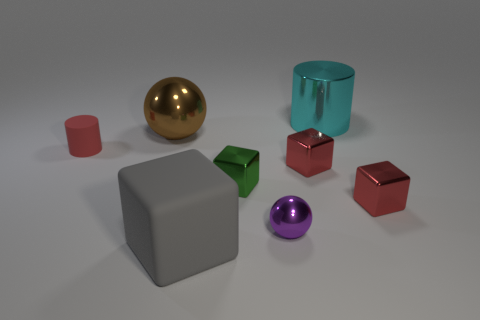Does the red thing on the left side of the big brown metal sphere have the same shape as the shiny object behind the large brown metal ball?
Your response must be concise. Yes. How many purple things are to the left of the metallic cylinder?
Give a very brief answer. 1. Is the big cube that is in front of the cyan cylinder made of the same material as the small red cylinder?
Provide a succinct answer. Yes. What is the color of the shiny thing that is the same shape as the red matte object?
Offer a terse response. Cyan. What shape is the big gray thing?
Your answer should be very brief. Cube. How many things are either big gray rubber blocks or small green shiny cubes?
Offer a terse response. 2. Is the color of the metallic block in front of the green metal thing the same as the matte object that is behind the tiny purple metallic sphere?
Keep it short and to the point. Yes. What number of other objects are the same shape as the tiny green thing?
Offer a very short reply. 3. Is there a tiny red rubber ball?
Make the answer very short. No. What number of things are tiny gray objects or large things that are on the left side of the large matte block?
Offer a terse response. 1. 